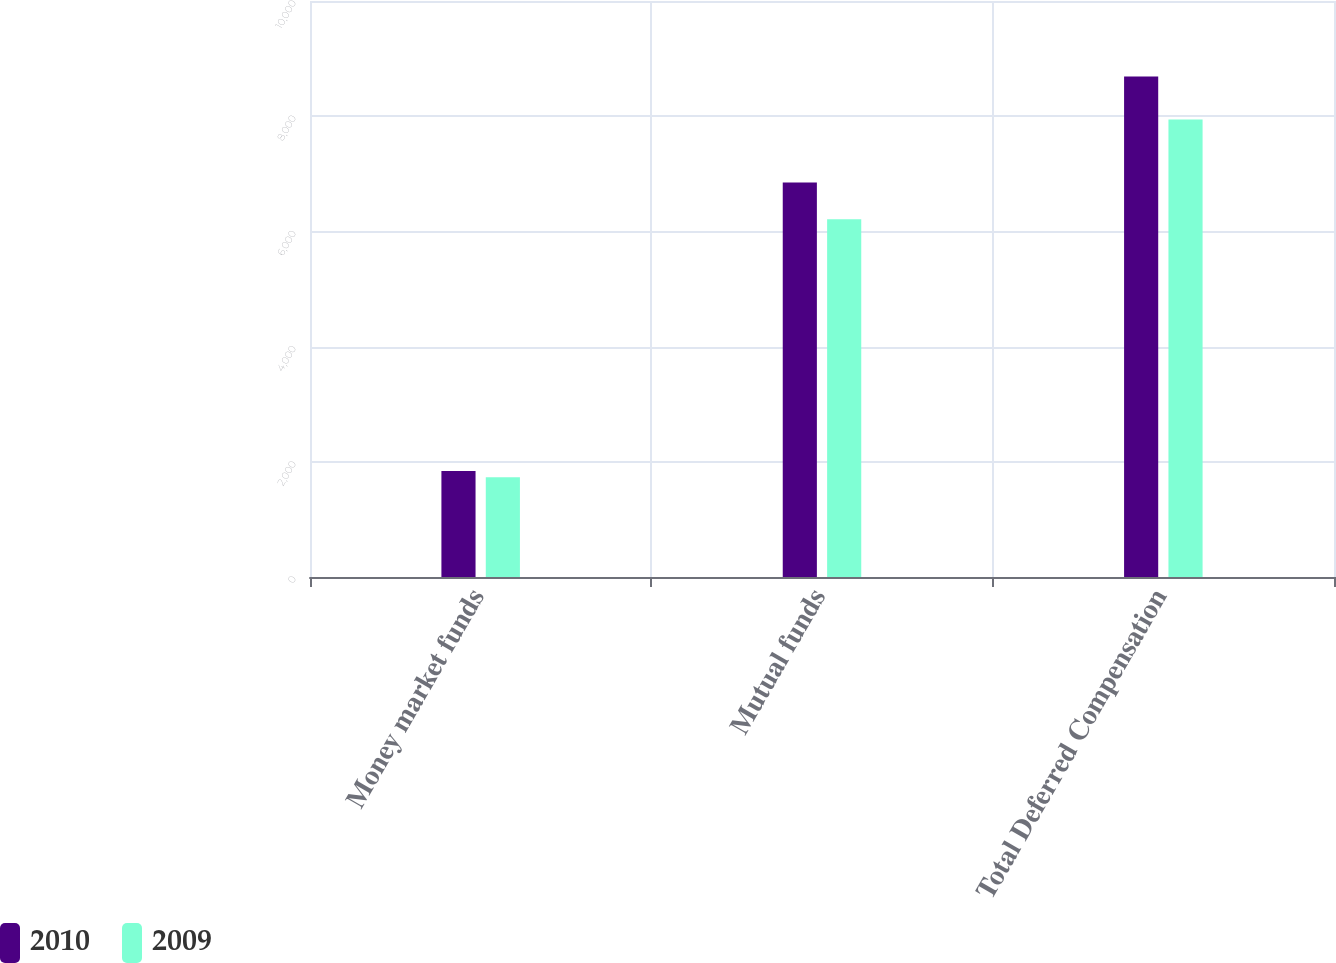<chart> <loc_0><loc_0><loc_500><loc_500><stacked_bar_chart><ecel><fcel>Money market funds<fcel>Mutual funds<fcel>Total Deferred Compensation<nl><fcel>2010<fcel>1840<fcel>6850<fcel>8690<nl><fcel>2009<fcel>1730<fcel>6213<fcel>7943<nl></chart> 